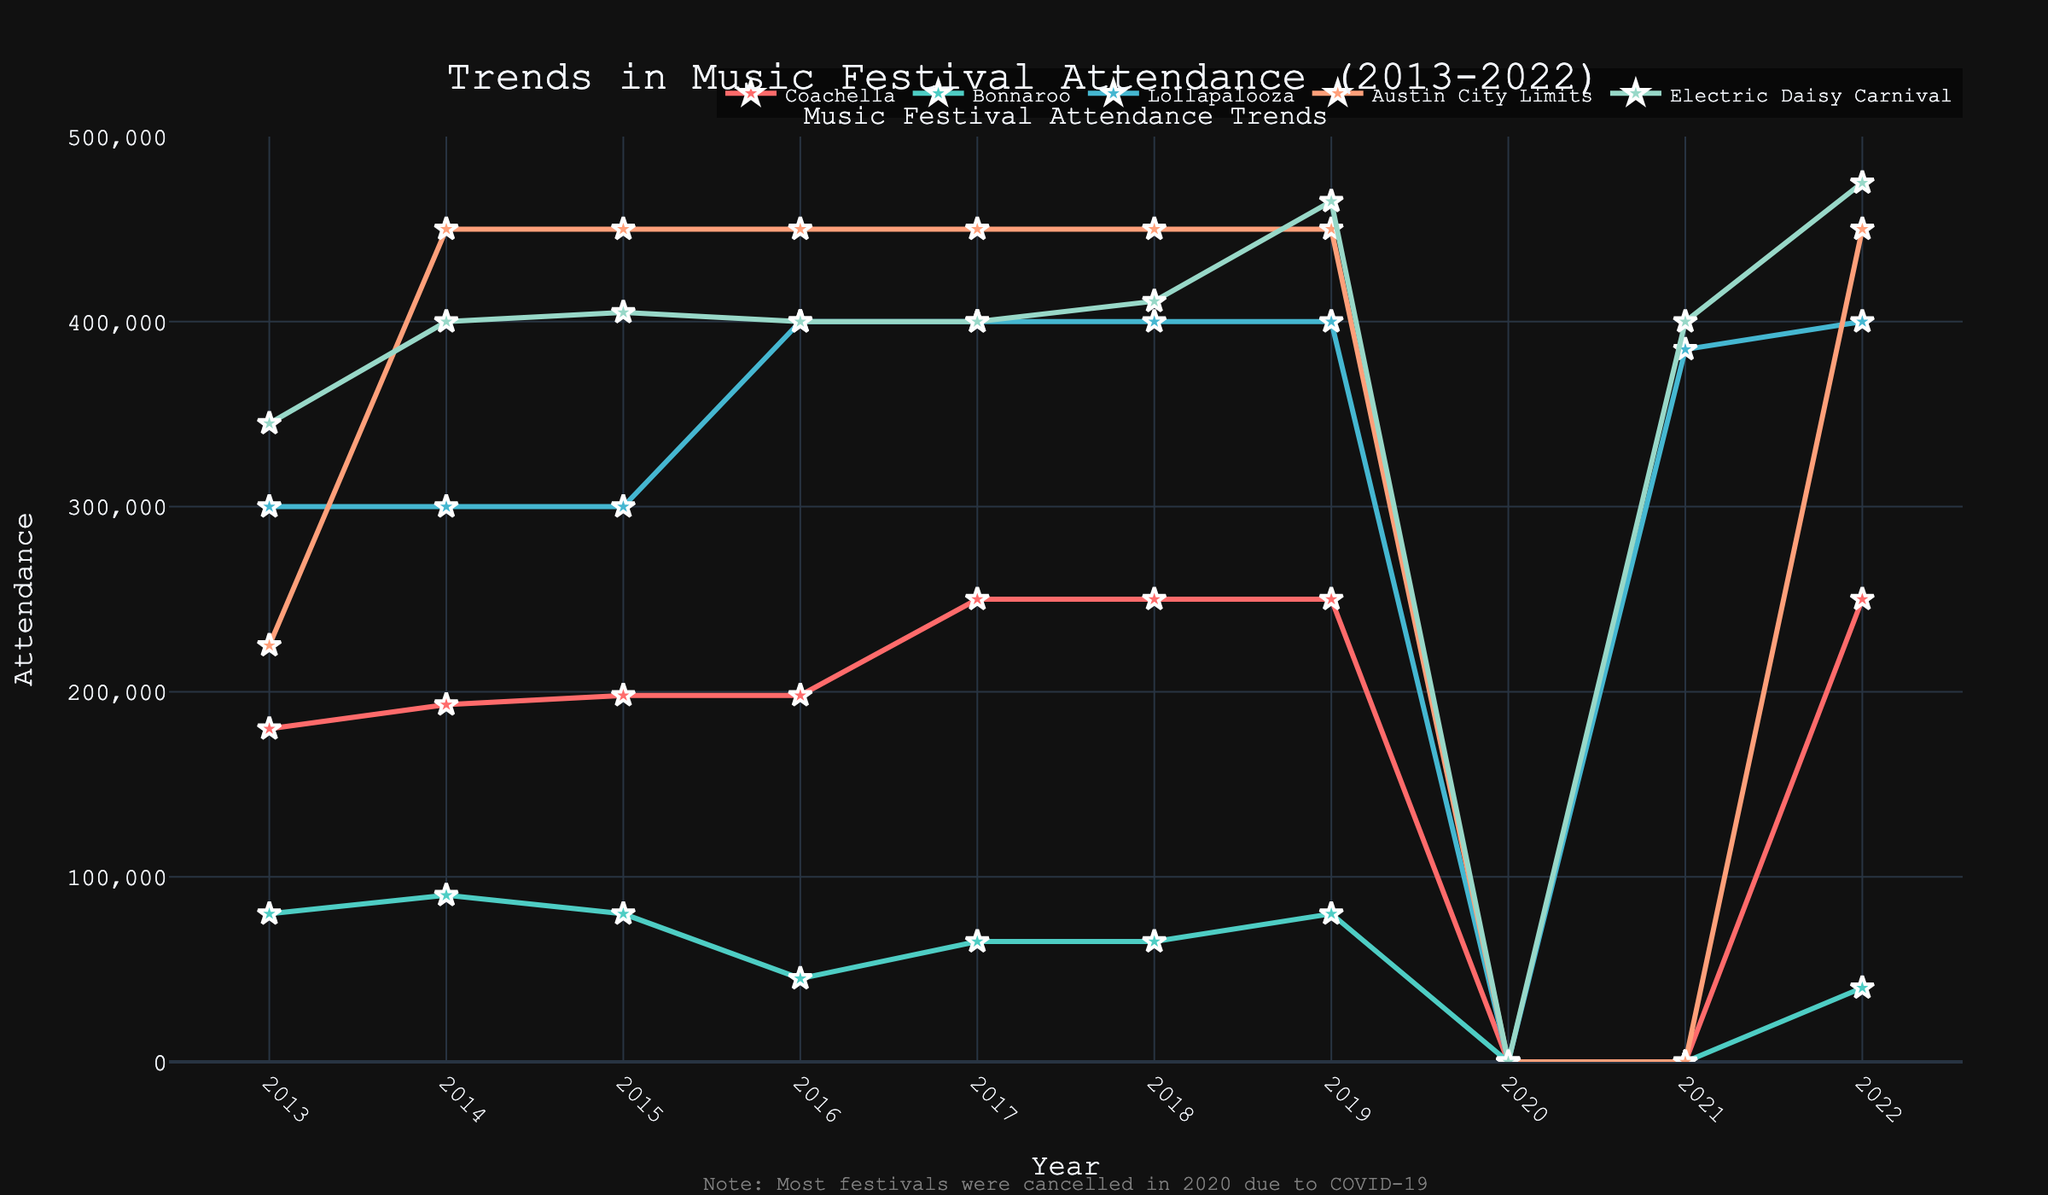What was the highest attendance for Coachella in the past decade? Look at the line associated with Coachella and identify the peak. The highest attendance is in years 2017 and from 2018 to 2022, where it reached 250,000.
Answer: 250,000 Which festival had zero attendance in both 2020 and 2021? Find the lines where the attendance drops to 0 for both years. For 2020, all festivals had zero, but in 2021, Coachella, Bonnaroo, and Austin City Limits still had zero.
Answer: Coachella, Bonnaroo, and Austin City Limits Compare the attendance trends of Lollapalooza and Bonnaroo from 2013 to 2022. Which festival had more consistent attendance? Evaluate the changes in the lines for both festivals. Bonnaroo shows high variability, dropping dramatically in 2016, while Lollapalooza maintains higher and more consistent attendance figures throughout the years.
Answer: Lollapalooza What is the total attendance for Electric Daisy Carnival across all the years provided? Sum the attendance numbers for Electric Daisy Carnival: 345,000 + 400,000 + 405,000 + 400,000 + 400,000 + 411,000 + 465,000 + 0 + 400,000 + 475,000 = 3,701,000.
Answer: 3,701,000 Which year had the lowest attendance for Bonnaroo, and what was the attendance figure that year? Look at the line corresponding to Bonnaroo and find the minimum point, which is in 2016 with an attendance of 45,000.
Answer: 2016, 45,000 How did the attendance for Austin City Limits change from 2013 to 2022? Review the trend line for Austin City Limits. It starts at 225,000 in 2013 and consistently rises to 450,000 in 2014 and maintains this value until 2022, with a drop to 0 in 2020 and no data for 2021.
Answer: Increased and stabilized at 450,000 What was the average attendance of Lollapalooza from 2013 to 2022? Calculate the average by summing up the attendance figures for Lollapalooza: 300,000*3 + 400,000*5 + 0 + 385,000 and then divide by 9 (as 2020 is excluded). That's (900,000 + 2,000,000 + 0 + 385,000) / 9 = 3,285,000 / 9 ≈ 365,000.
Answer: 365,000 How many times did the attendance for Coachella exceed 200,000? Identify the years where the line for Coachella is above the 200,000 mark. The years are: 2017, 2018, 2019, 2022.
Answer: 4 In which years did the attendance for Coachella and Electric Daisy Carnival equal each other? Compare the attendance figures for both festivals year by year. They were equal in 2014 at 400,000, 2015 both were around 400,000, and from 2016 to 2021, they were very close but not equal.
Answer: None 